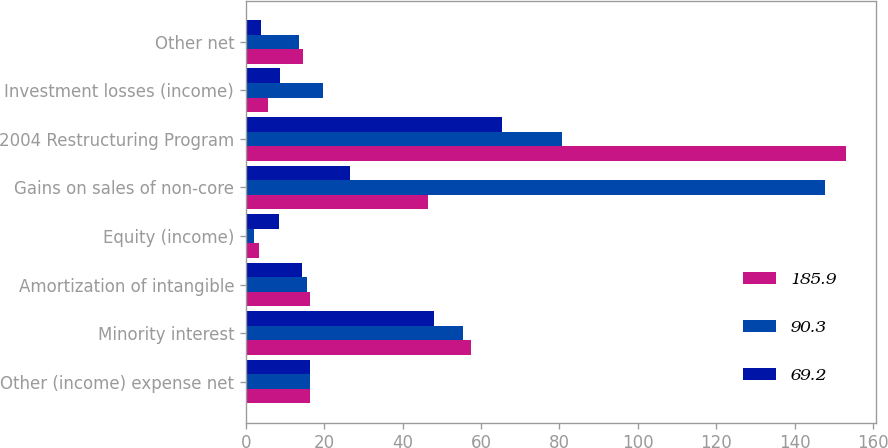Convert chart. <chart><loc_0><loc_0><loc_500><loc_500><stacked_bar_chart><ecel><fcel>Other (income) expense net<fcel>Minority interest<fcel>Amortization of intangible<fcel>Equity (income)<fcel>Gains on sales of non-core<fcel>2004 Restructuring Program<fcel>Investment losses (income)<fcel>Other net<nl><fcel>185.9<fcel>16.3<fcel>57.5<fcel>16.3<fcel>3.4<fcel>46.5<fcel>153.1<fcel>5.7<fcel>14.6<nl><fcel>90.3<fcel>16.3<fcel>55.3<fcel>15.6<fcel>2<fcel>147.9<fcel>80.8<fcel>19.7<fcel>13.7<nl><fcel>69.2<fcel>16.3<fcel>47.9<fcel>14.3<fcel>8.5<fcel>26.7<fcel>65.3<fcel>8.7<fcel>3.9<nl></chart> 